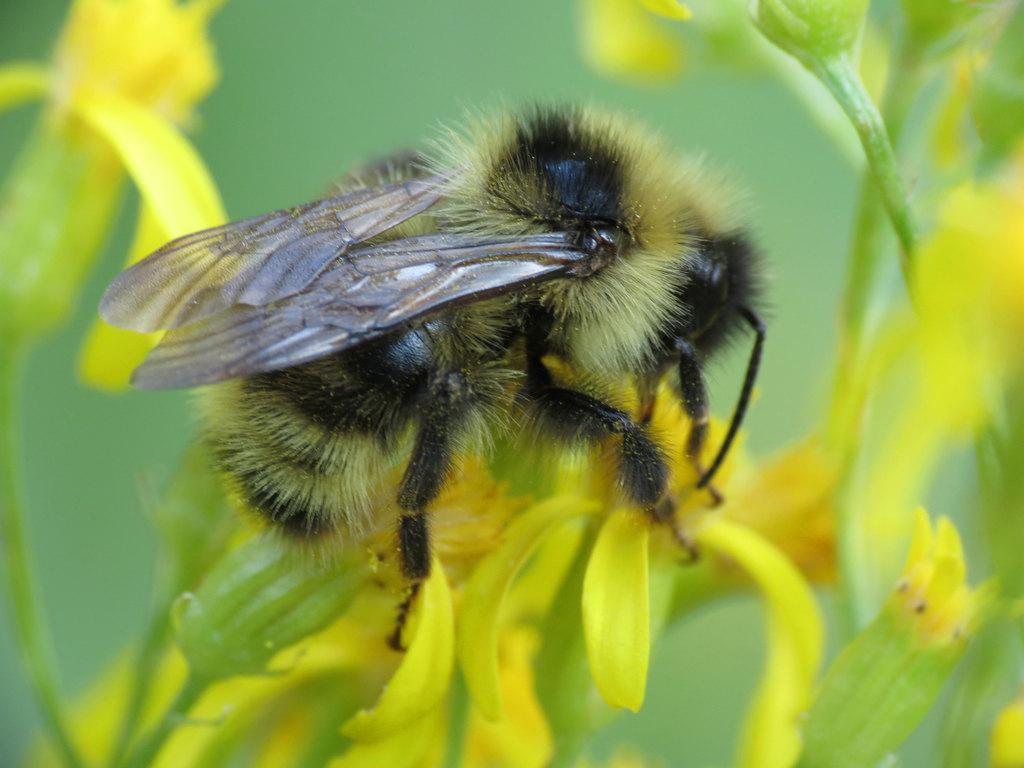Describe this image in one or two sentences. In the center of the image there is a fly on the flower. 